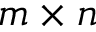<formula> <loc_0><loc_0><loc_500><loc_500>m \times n</formula> 